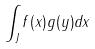Convert formula to latex. <formula><loc_0><loc_0><loc_500><loc_500>\int _ { J } f ( x ) g ( y ) d x</formula> 